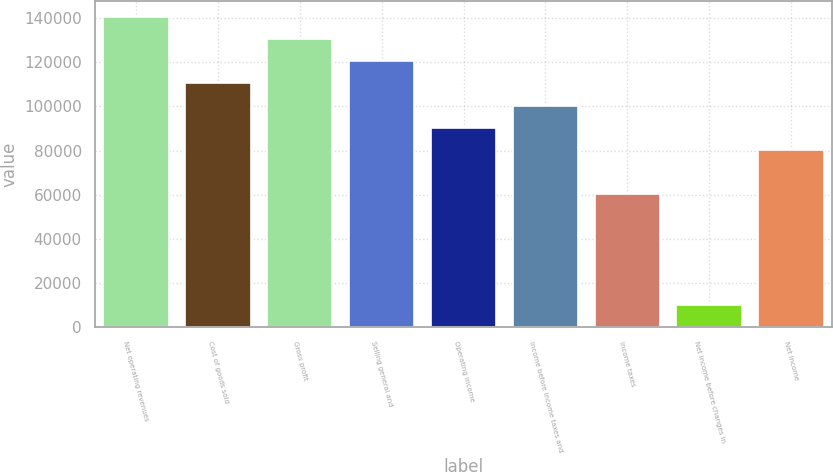Convert chart to OTSL. <chart><loc_0><loc_0><loc_500><loc_500><bar_chart><fcel>Net operating revenues<fcel>Cost of goods sold<fcel>Gross profit<fcel>Selling general and<fcel>Operating income<fcel>Income before income taxes and<fcel>Income taxes<fcel>Net income before changes in<fcel>Net income<nl><fcel>140455<fcel>110357<fcel>130422<fcel>120390<fcel>90292.6<fcel>100325<fcel>60195.4<fcel>10033.4<fcel>80260.2<nl></chart> 